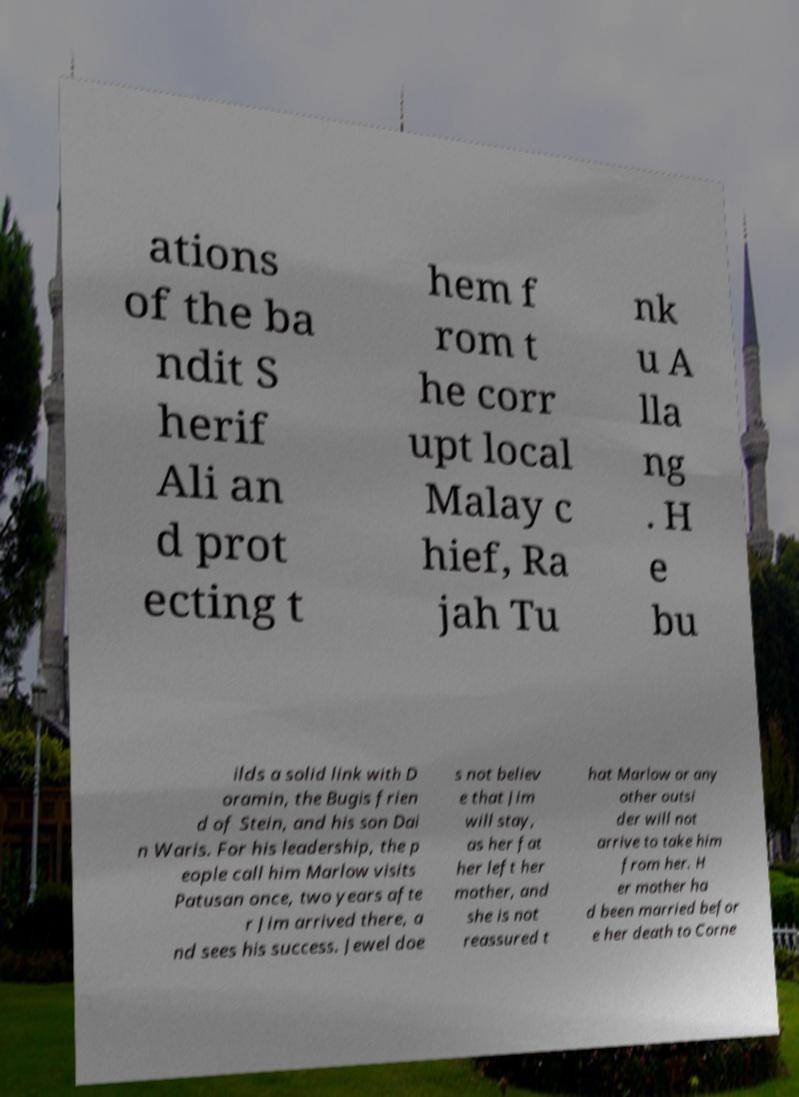What messages or text are displayed in this image? I need them in a readable, typed format. ations of the ba ndit S herif Ali an d prot ecting t hem f rom t he corr upt local Malay c hief, Ra jah Tu nk u A lla ng . H e bu ilds a solid link with D oramin, the Bugis frien d of Stein, and his son Dai n Waris. For his leadership, the p eople call him Marlow visits Patusan once, two years afte r Jim arrived there, a nd sees his success. Jewel doe s not believ e that Jim will stay, as her fat her left her mother, and she is not reassured t hat Marlow or any other outsi der will not arrive to take him from her. H er mother ha d been married befor e her death to Corne 